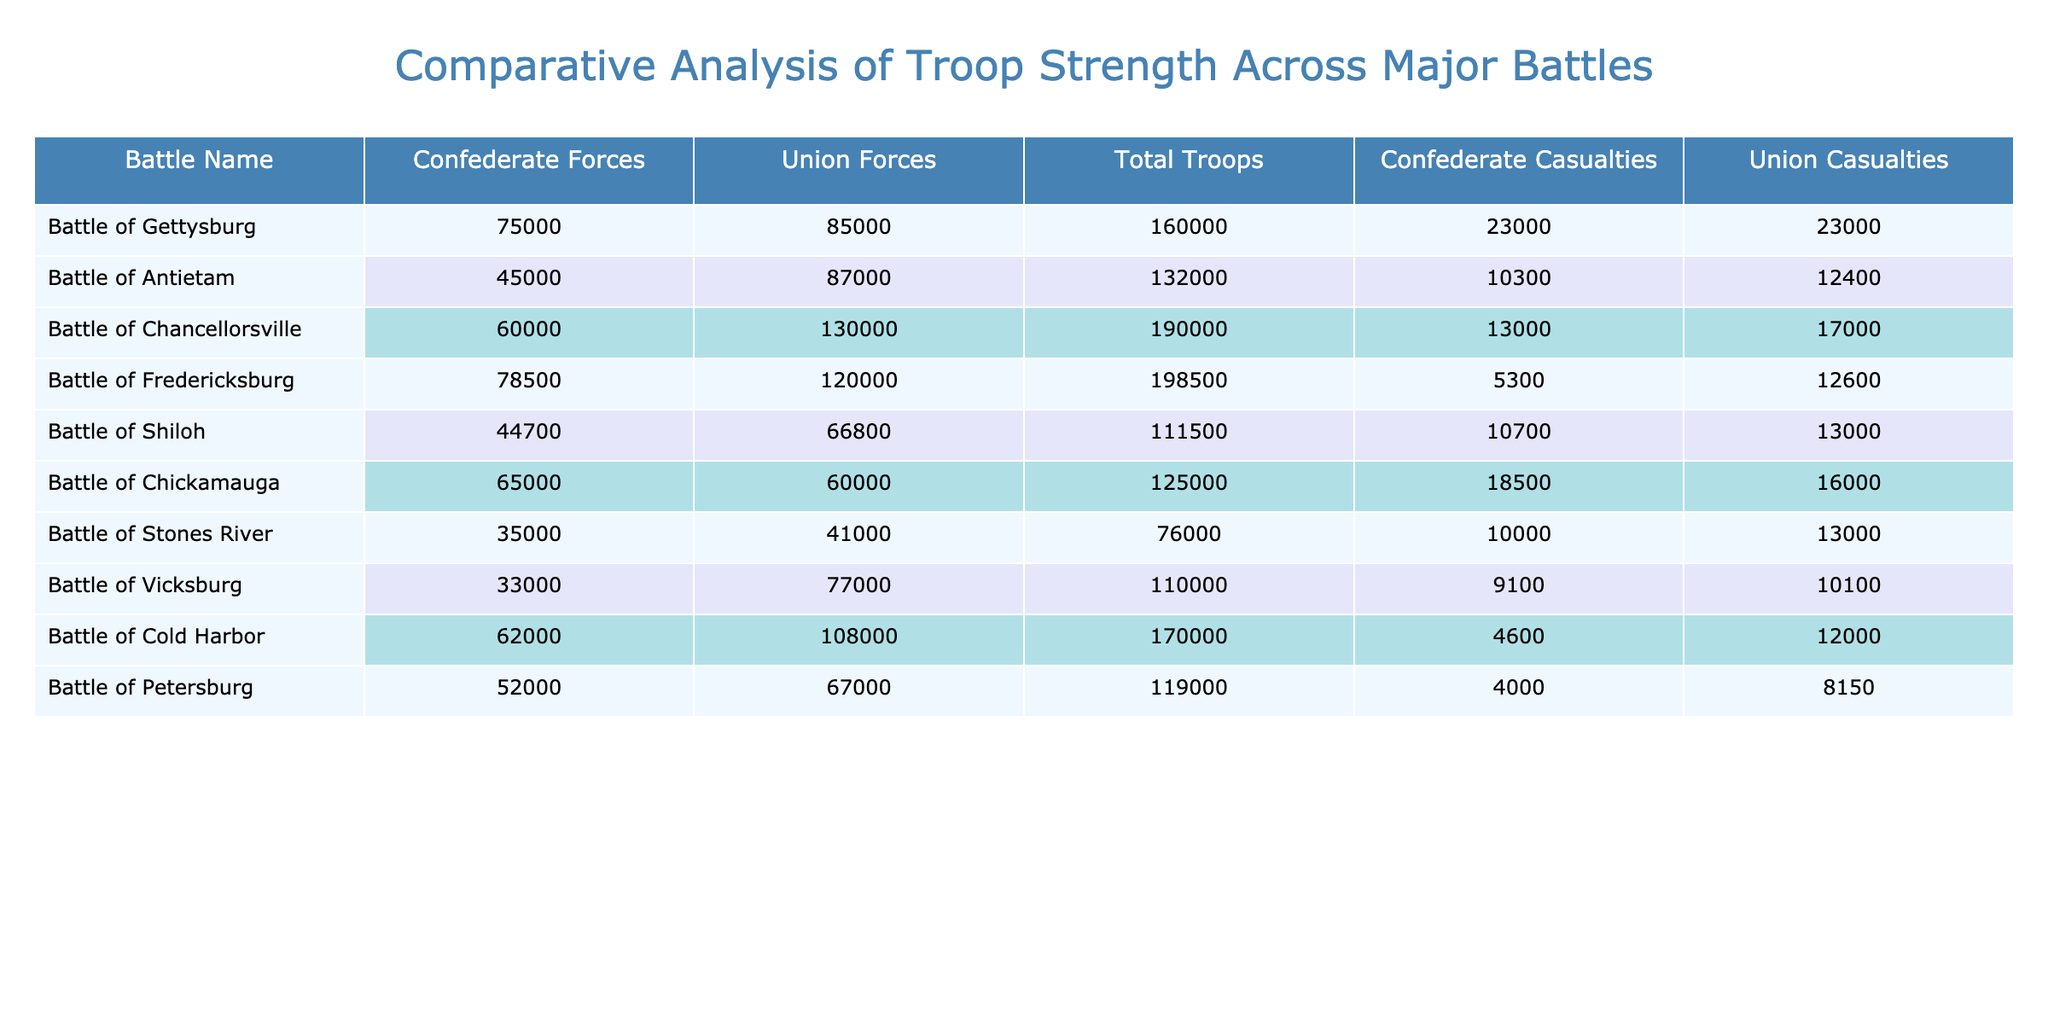What was the troop strength in the Battle of Gettysburg? According to the table, the Confederate Forces were 75,000 and the Union Forces were 85,000. Summing these gives the Total Troops: 75,000 + 85,000 = 160,000.
Answer: 160,000 Which battle had the least total troops? By examining the Total Troops column, the Battle of Stones River has the lowest value at 76,000.
Answer: 76,000 What was the casualty ratio (Confederate to Union) in the Battle of Antietam? The Confederate Casualties were 10,300 and the Union Casualties were 12,400. The ratio is 10,300 / 12,400, which simplifies to about 0.83.
Answer: 0.83 How many more Union Forces were present in the Battle of Fredericksburg compared to Confederate Forces? The Union Forces were 120,000 and Confederate Forces were 78,500. The difference is 120,000 - 78,500 = 41,500.
Answer: 41,500 Which battle resulted in the highest number of casualties for the Confederates? Looking at the Confederate Casualties column, the Battle of Chickamauga shows the highest value at 18,500.
Answer: 18,500 In which battle did the Union Forces suffer fewer casualties than Confederate Forces? Analyzing the Casualties columns, the Battle of Cold Harbor shows Union casualties of 12,000 which is fewer than Confederate casualties of 4,600. Thus, this statement is false, and there are no battles that meet the criteria.
Answer: False What is the average number of Confederate Forces across all battles? To find the average, sum the Confederate Forces (75,000 + 45,000 + 60,000 + 78,500 + 44,700 + 65,000 + 35,000 + 33,000 + 62,000 + 52,000) which equals  60,120 and divide by 10 (the number of battles), resulting in 6,012.
Answer: 60,120 Which battle had the highest total troop deployment? Checking the Total Troops column, the Battle of Chancellorsville has the maximum value at 190,000.
Answer: 190,000 What is the difference in total troop strength between the Battles of Chancellorsville and Vicksburg? Total for Chancellorsville is 190,000 and Vicksburg is 110,000. The difference is 190,000 - 110,000 = 80,000.
Answer: 80,000 What percentage of total troops were Confederate during the Battle of Chickamauga? For Chickamauga, the total troops were 125,000 with Confederate Forces being 65,000. The percentage is (65,000 / 125,000) * 100 = 52%.
Answer: 52% 